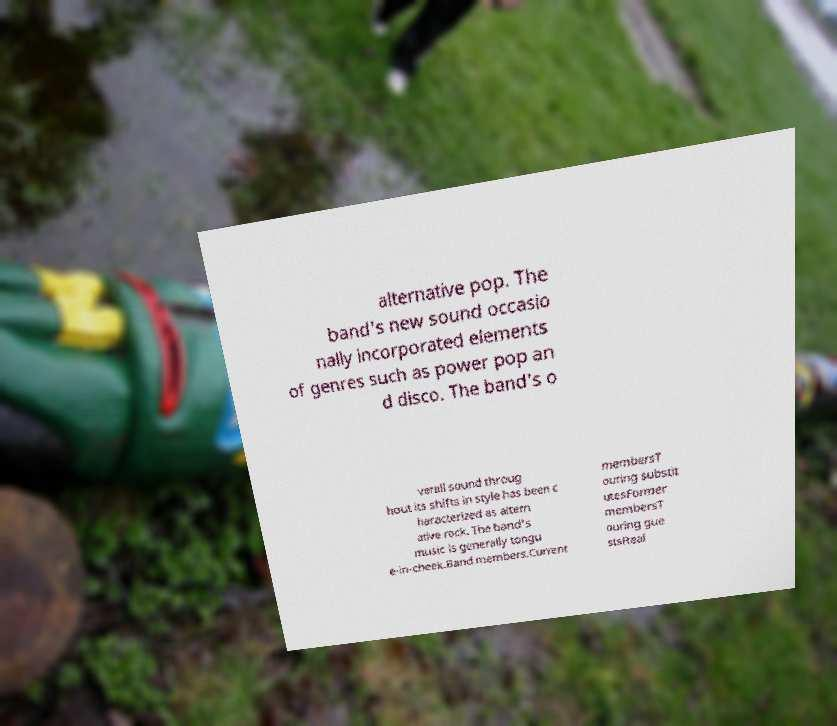Could you extract and type out the text from this image? alternative pop. The band's new sound occasio nally incorporated elements of genres such as power pop an d disco. The band's o verall sound throug hout its shifts in style has been c haracterized as altern ative rock. The band's music is generally tongu e-in-cheek.Band members.Current membersT ouring substit utesFormer membersT ouring gue stsReal 